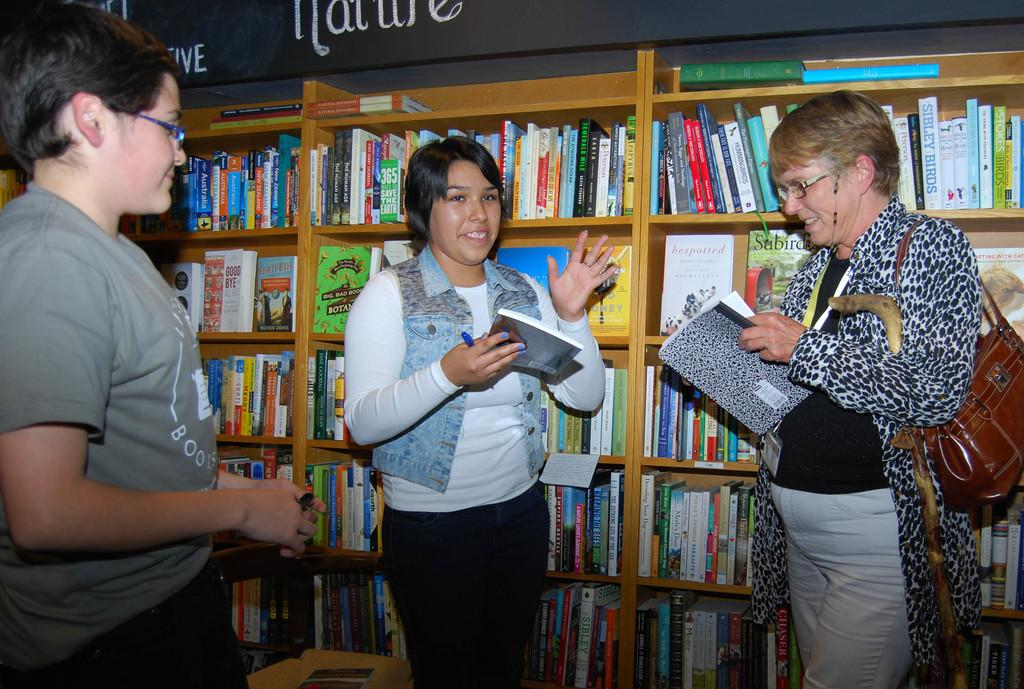<image>
Write a terse but informative summary of the picture. The green book is called the Big, Bad, Book of Botanicals 